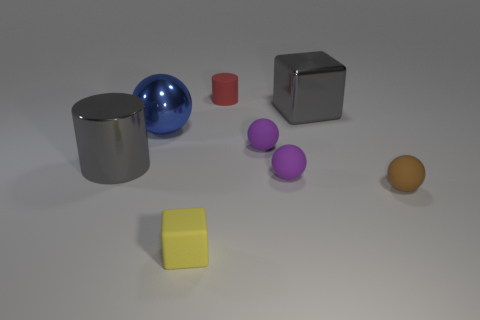What color is the metallic thing that is behind the large gray cylinder and to the left of the yellow object? The metallic object situated behind the large gray cylinder and to the left of the yellow cube appears to be blue, reflecting some of the environment on its shiny surface. 